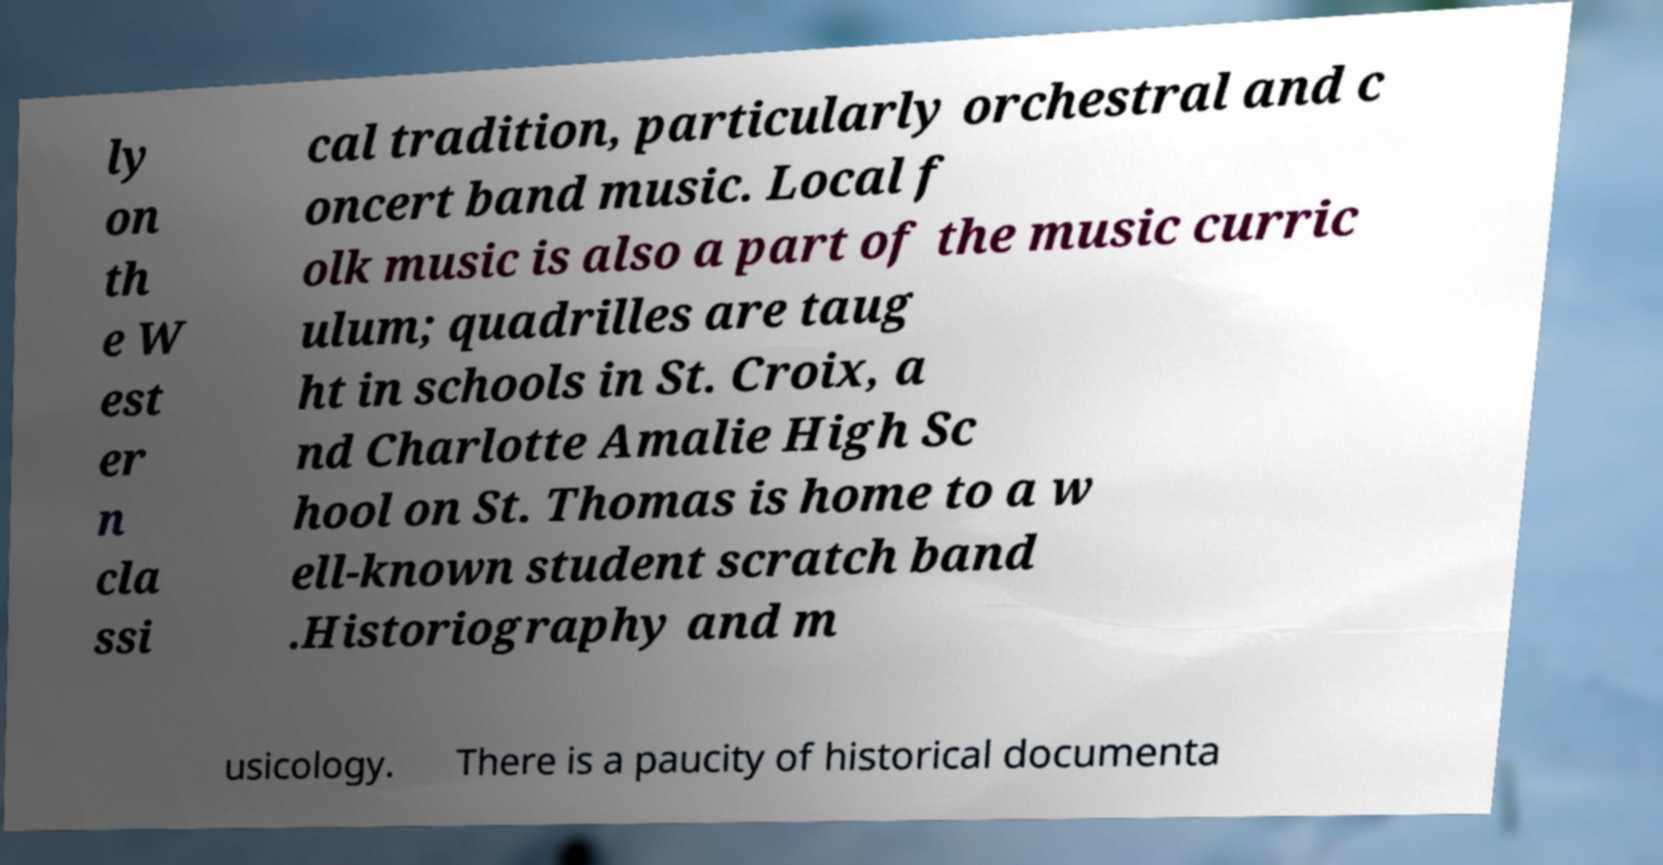Please read and relay the text visible in this image. What does it say? ly on th e W est er n cla ssi cal tradition, particularly orchestral and c oncert band music. Local f olk music is also a part of the music curric ulum; quadrilles are taug ht in schools in St. Croix, a nd Charlotte Amalie High Sc hool on St. Thomas is home to a w ell-known student scratch band .Historiography and m usicology. There is a paucity of historical documenta 